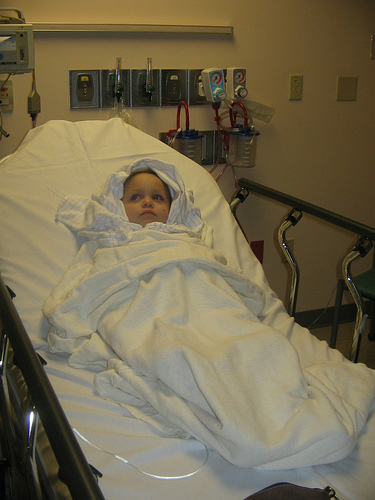<image>
Is there a child in the blanket? Yes. The child is contained within or inside the blanket, showing a containment relationship. 